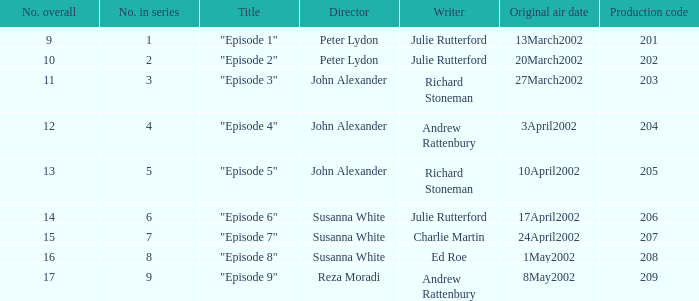When the total number is 15, what was the original date of airing? 24April2002. Could you parse the entire table? {'header': ['No. overall', 'No. in series', 'Title', 'Director', 'Writer', 'Original air date', 'Production code'], 'rows': [['9', '1', '"Episode 1"', 'Peter Lydon', 'Julie Rutterford', '13March2002', '201'], ['10', '2', '"Episode 2"', 'Peter Lydon', 'Julie Rutterford', '20March2002', '202'], ['11', '3', '"Episode 3"', 'John Alexander', 'Richard Stoneman', '27March2002', '203'], ['12', '4', '"Episode 4"', 'John Alexander', 'Andrew Rattenbury', '3April2002', '204'], ['13', '5', '"Episode 5"', 'John Alexander', 'Richard Stoneman', '10April2002', '205'], ['14', '6', '"Episode 6"', 'Susanna White', 'Julie Rutterford', '17April2002', '206'], ['15', '7', '"Episode 7"', 'Susanna White', 'Charlie Martin', '24April2002', '207'], ['16', '8', '"Episode 8"', 'Susanna White', 'Ed Roe', '1May2002', '208'], ['17', '9', '"Episode 9"', 'Reza Moradi', 'Andrew Rattenbury', '8May2002', '209']]} 